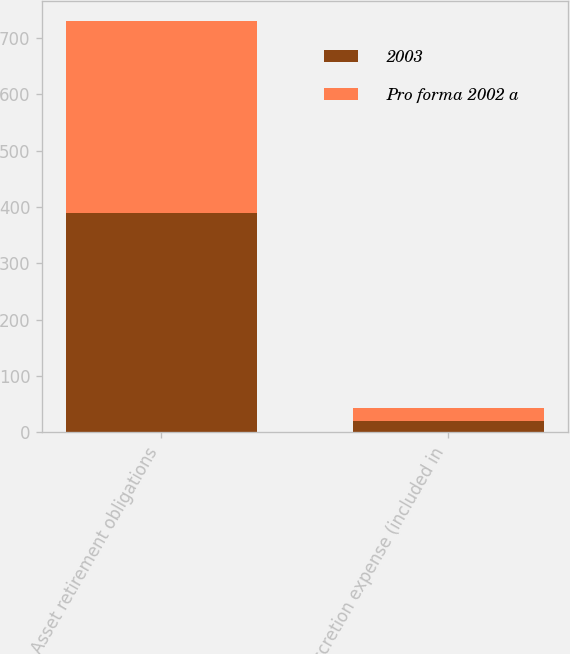Convert chart to OTSL. <chart><loc_0><loc_0><loc_500><loc_500><stacked_bar_chart><ecel><fcel>Asset retirement obligations<fcel>Accretion expense (included in<nl><fcel>2003<fcel>390<fcel>20<nl><fcel>Pro forma 2002 a<fcel>339<fcel>23<nl></chart> 